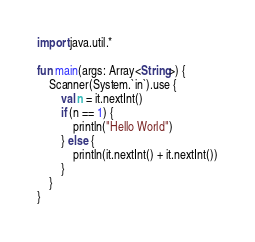Convert code to text. <code><loc_0><loc_0><loc_500><loc_500><_Kotlin_>import java.util.*

fun main(args: Array<String>) {
    Scanner(System.`in`).use {
        val n = it.nextInt()
        if (n == 1) {
            println("Hello World")
        } else {
            println(it.nextInt() + it.nextInt())
        }
    }
}
</code> 